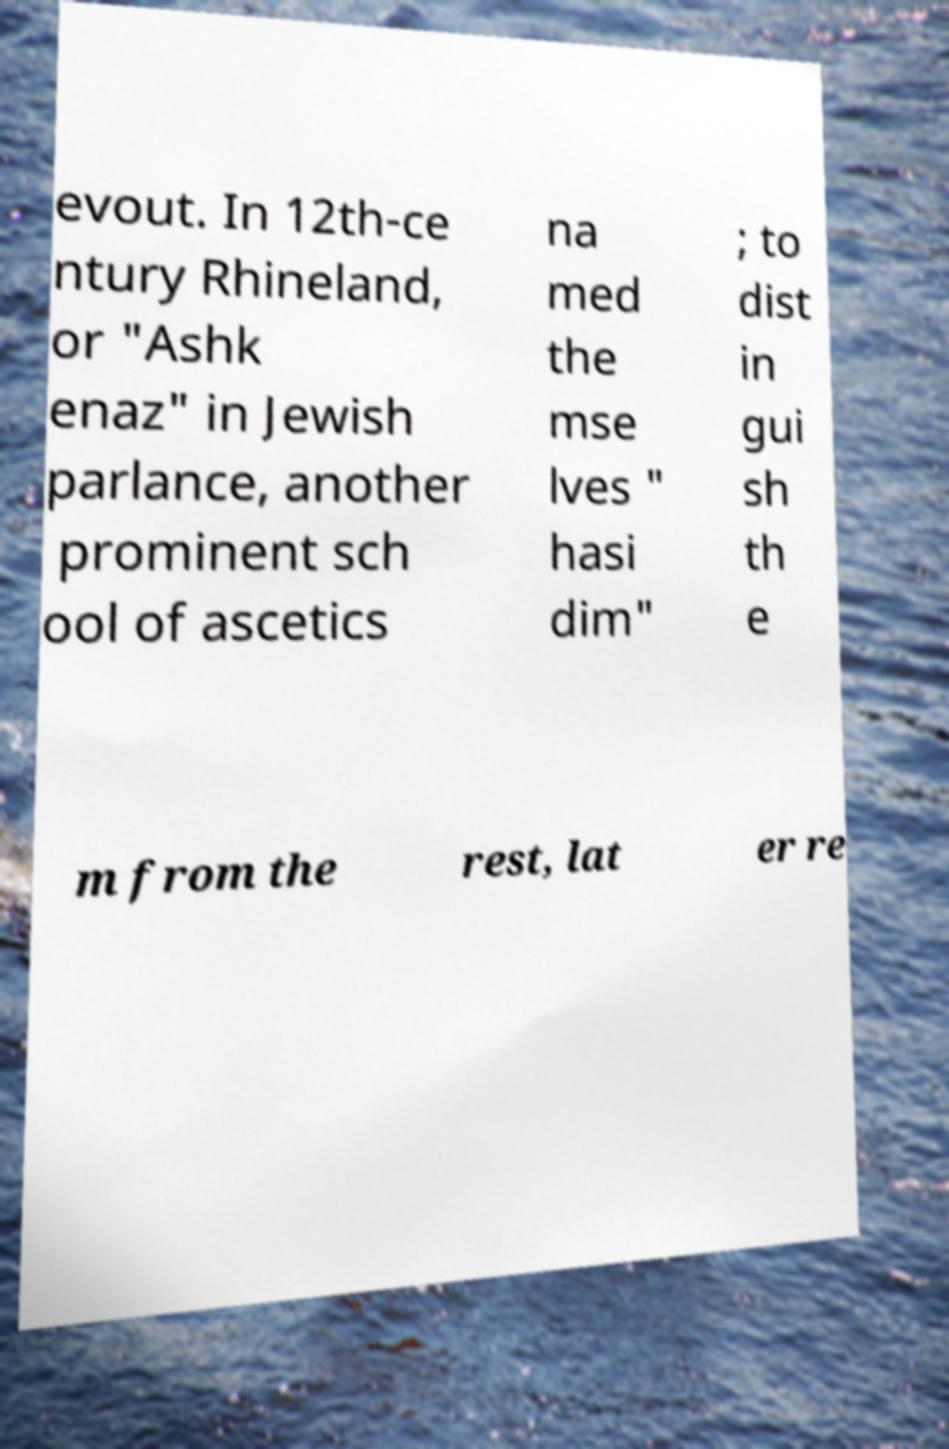Could you assist in decoding the text presented in this image and type it out clearly? evout. In 12th-ce ntury Rhineland, or "Ashk enaz" in Jewish parlance, another prominent sch ool of ascetics na med the mse lves " hasi dim" ; to dist in gui sh th e m from the rest, lat er re 